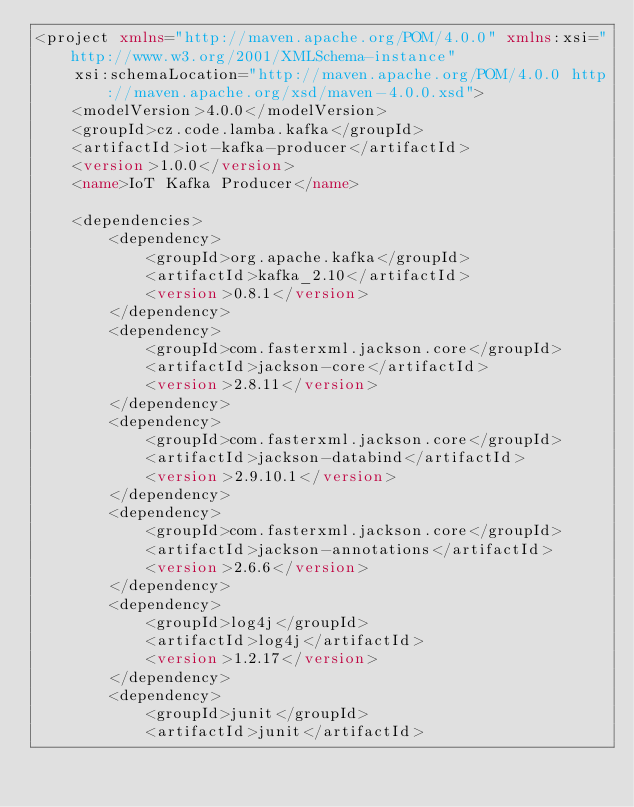<code> <loc_0><loc_0><loc_500><loc_500><_XML_><project xmlns="http://maven.apache.org/POM/4.0.0" xmlns:xsi="http://www.w3.org/2001/XMLSchema-instance"
	xsi:schemaLocation="http://maven.apache.org/POM/4.0.0 http://maven.apache.org/xsd/maven-4.0.0.xsd">
	<modelVersion>4.0.0</modelVersion>
	<groupId>cz.code.lamba.kafka</groupId>
	<artifactId>iot-kafka-producer</artifactId>
	<version>1.0.0</version>
	<name>IoT Kafka Producer</name>

	<dependencies>
		<dependency>
			<groupId>org.apache.kafka</groupId>
			<artifactId>kafka_2.10</artifactId>
			<version>0.8.1</version>
		</dependency>
		<dependency>
			<groupId>com.fasterxml.jackson.core</groupId>
			<artifactId>jackson-core</artifactId>
			<version>2.8.11</version>
		</dependency>
		<dependency>
			<groupId>com.fasterxml.jackson.core</groupId>
			<artifactId>jackson-databind</artifactId>
			<version>2.9.10.1</version>
		</dependency>
		<dependency>
			<groupId>com.fasterxml.jackson.core</groupId>
			<artifactId>jackson-annotations</artifactId>
			<version>2.6.6</version>
		</dependency>
		<dependency>
			<groupId>log4j</groupId>
			<artifactId>log4j</artifactId>
			<version>1.2.17</version>
		</dependency>
		<dependency>
			<groupId>junit</groupId>
			<artifactId>junit</artifactId></code> 